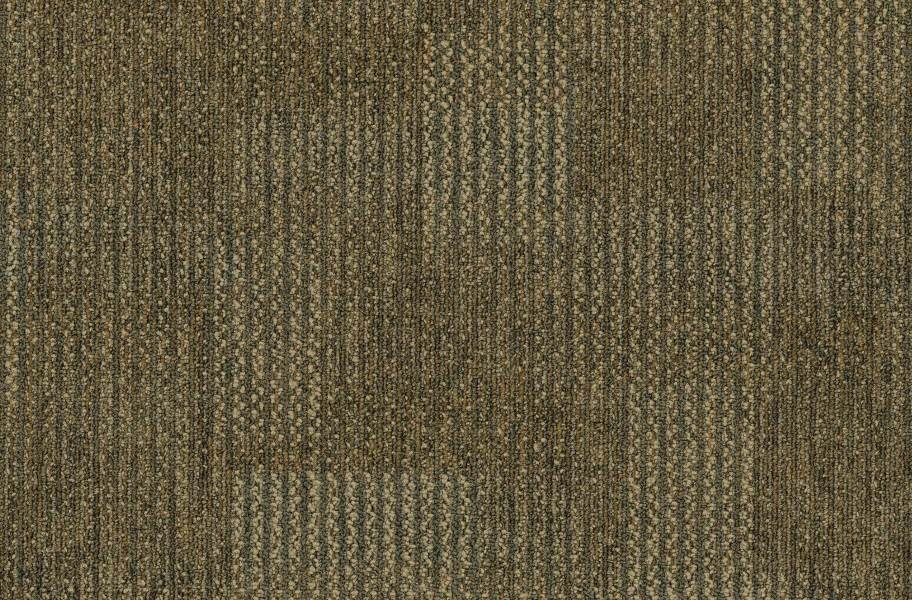What type of weave pattern is exhibited in the fabric, and how might this affect its functional properties? The fabric shows a sophisticated herringbone weave pattern, characterized by a zigzagging appearance. This specific weave is not only aesthetically pleasing but is engineered to offer increased durability and structural integrity. The interlocking nature of the herringbone pattern enhances the fabric's resistance to wrinkles and stretching, making it an excellent choice for upholstery and garments that encounter frequent use. Moreover, the tightness of the weave ensures minimal moisture absorption, which can be beneficial for outdoor wear. While highly durable, the complexity of this weave can make the fabric slightly stiffer and less breathable compared to simpler weaves like plain or twill, which might not be ideal for all clothing applications. 